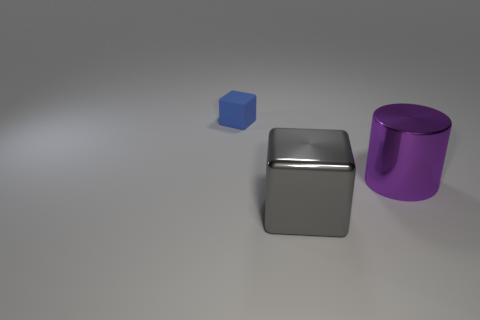How many objects are metallic cubes or small red metallic cylinders?
Make the answer very short. 1. Is there anything else that is made of the same material as the big gray block?
Keep it short and to the point. Yes. The large purple metal thing has what shape?
Your answer should be very brief. Cylinder. There is a large object behind the block that is right of the tiny blue object; what is its shape?
Make the answer very short. Cylinder. Do the blue block that is on the left side of the large purple cylinder and the purple object have the same material?
Make the answer very short. No. What number of red objects are either cubes or large metal cylinders?
Your response must be concise. 0. Is there a small shiny thing that has the same color as the cylinder?
Ensure brevity in your answer.  No. Is there a small gray thing that has the same material as the purple object?
Offer a terse response. No. What is the shape of the object that is on the left side of the purple metal thing and behind the large gray cube?
Provide a short and direct response. Cube. How many small objects are yellow metal cubes or metal cubes?
Your answer should be compact. 0. 